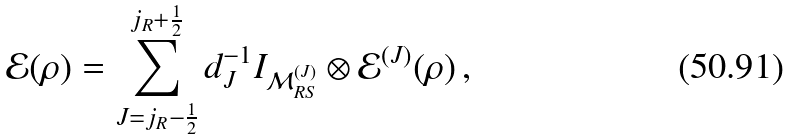<formula> <loc_0><loc_0><loc_500><loc_500>\mathcal { E } ( \rho ) = \sum _ { J = j _ { R } - \frac { 1 } { 2 } } ^ { j _ { R } + \frac { 1 } { 2 } } d _ { J } ^ { - 1 } I _ { \mathcal { M } _ { R S } ^ { ( J ) } } \otimes \mathcal { E } ^ { ( J ) } ( \rho ) \, ,</formula> 